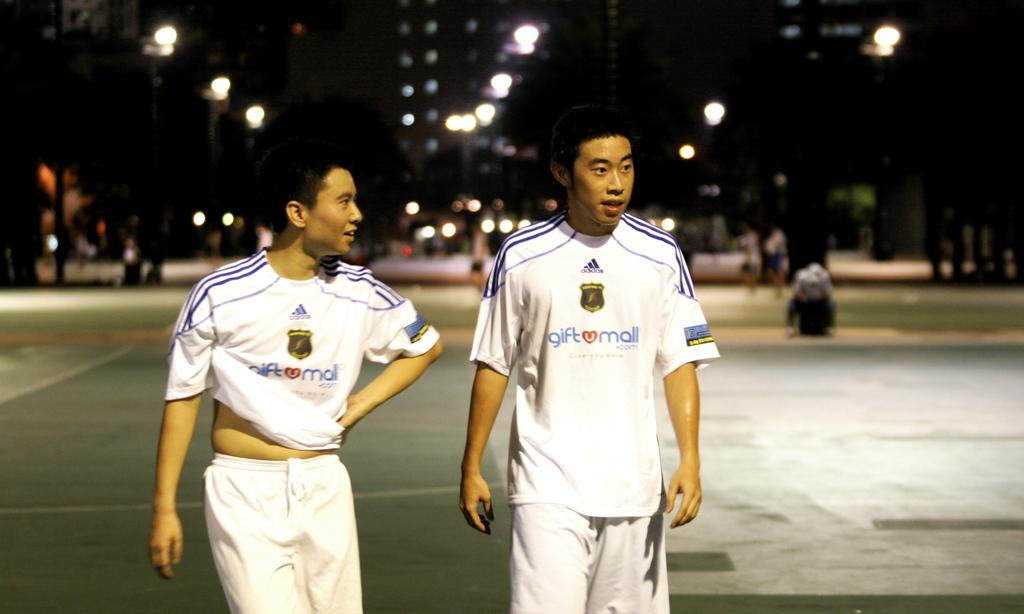<image>
Present a compact description of the photo's key features. Two male walking down the street in shirts that say "giftumail" on them. 